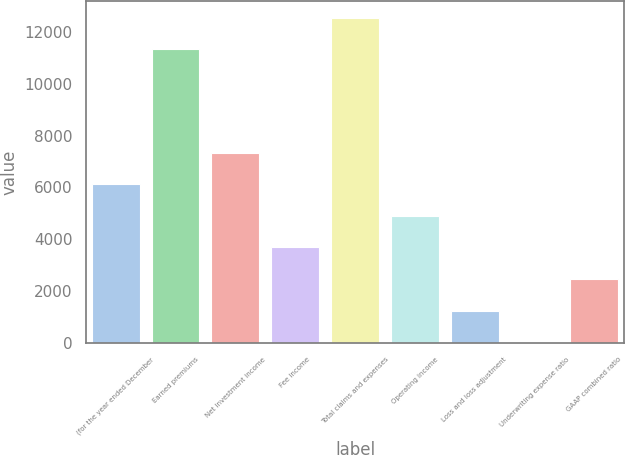<chart> <loc_0><loc_0><loc_500><loc_500><bar_chart><fcel>(for the year ended December<fcel>Earned premiums<fcel>Net investment income<fcel>Fee income<fcel>Total claims and expenses<fcel>Operating income<fcel>Loss and loss adjustment<fcel>Underwriting expense ratio<fcel>GAAP combined ratio<nl><fcel>6118.8<fcel>11327<fcel>7336.24<fcel>3683.92<fcel>12544.4<fcel>4901.36<fcel>1249.04<fcel>31.6<fcel>2466.48<nl></chart> 